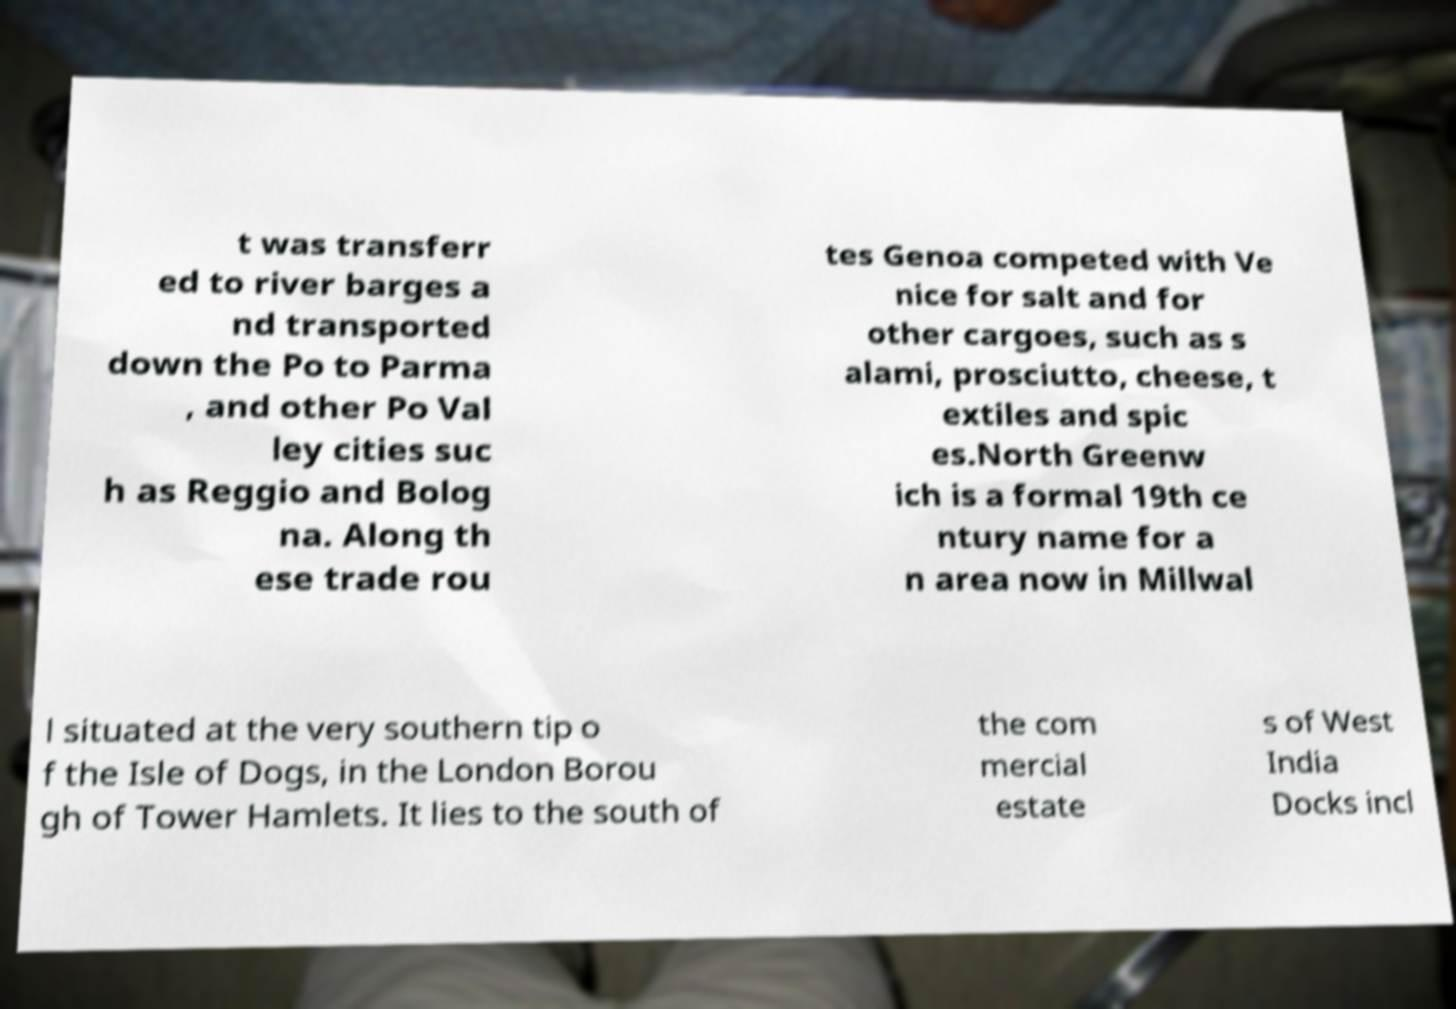Could you extract and type out the text from this image? t was transferr ed to river barges a nd transported down the Po to Parma , and other Po Val ley cities suc h as Reggio and Bolog na. Along th ese trade rou tes Genoa competed with Ve nice for salt and for other cargoes, such as s alami, prosciutto, cheese, t extiles and spic es.North Greenw ich is a formal 19th ce ntury name for a n area now in Millwal l situated at the very southern tip o f the Isle of Dogs, in the London Borou gh of Tower Hamlets. It lies to the south of the com mercial estate s of West India Docks incl 